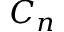Convert formula to latex. <formula><loc_0><loc_0><loc_500><loc_500>C _ { n }</formula> 